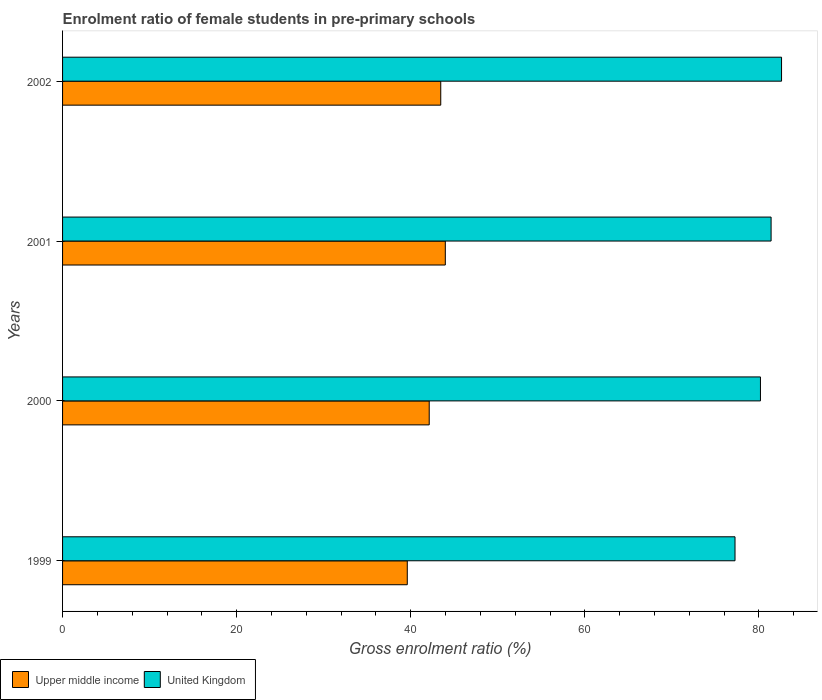How many different coloured bars are there?
Your answer should be compact. 2. Are the number of bars per tick equal to the number of legend labels?
Offer a terse response. Yes. Are the number of bars on each tick of the Y-axis equal?
Ensure brevity in your answer.  Yes. How many bars are there on the 2nd tick from the bottom?
Make the answer very short. 2. What is the label of the 2nd group of bars from the top?
Your response must be concise. 2001. What is the enrolment ratio of female students in pre-primary schools in United Kingdom in 2000?
Give a very brief answer. 80.17. Across all years, what is the maximum enrolment ratio of female students in pre-primary schools in United Kingdom?
Offer a very short reply. 82.6. Across all years, what is the minimum enrolment ratio of female students in pre-primary schools in Upper middle income?
Provide a short and direct response. 39.6. In which year was the enrolment ratio of female students in pre-primary schools in Upper middle income maximum?
Your answer should be very brief. 2001. In which year was the enrolment ratio of female students in pre-primary schools in Upper middle income minimum?
Keep it short and to the point. 1999. What is the total enrolment ratio of female students in pre-primary schools in United Kingdom in the graph?
Provide a succinct answer. 321.42. What is the difference between the enrolment ratio of female students in pre-primary schools in United Kingdom in 1999 and that in 2000?
Keep it short and to the point. -2.92. What is the difference between the enrolment ratio of female students in pre-primary schools in Upper middle income in 1999 and the enrolment ratio of female students in pre-primary schools in United Kingdom in 2002?
Offer a terse response. -43. What is the average enrolment ratio of female students in pre-primary schools in Upper middle income per year?
Keep it short and to the point. 42.29. In the year 2001, what is the difference between the enrolment ratio of female students in pre-primary schools in United Kingdom and enrolment ratio of female students in pre-primary schools in Upper middle income?
Offer a terse response. 37.43. What is the ratio of the enrolment ratio of female students in pre-primary schools in United Kingdom in 2000 to that in 2001?
Keep it short and to the point. 0.98. Is the enrolment ratio of female students in pre-primary schools in Upper middle income in 2000 less than that in 2001?
Give a very brief answer. Yes. Is the difference between the enrolment ratio of female students in pre-primary schools in United Kingdom in 2000 and 2002 greater than the difference between the enrolment ratio of female students in pre-primary schools in Upper middle income in 2000 and 2002?
Provide a succinct answer. No. What is the difference between the highest and the second highest enrolment ratio of female students in pre-primary schools in United Kingdom?
Provide a short and direct response. 1.2. What is the difference between the highest and the lowest enrolment ratio of female students in pre-primary schools in Upper middle income?
Your answer should be very brief. 4.37. What does the 1st bar from the bottom in 2000 represents?
Provide a succinct answer. Upper middle income. Are all the bars in the graph horizontal?
Ensure brevity in your answer.  Yes. What is the difference between two consecutive major ticks on the X-axis?
Offer a terse response. 20. Are the values on the major ticks of X-axis written in scientific E-notation?
Your answer should be compact. No. Where does the legend appear in the graph?
Your answer should be very brief. Bottom left. How are the legend labels stacked?
Offer a terse response. Horizontal. What is the title of the graph?
Give a very brief answer. Enrolment ratio of female students in pre-primary schools. Does "United States" appear as one of the legend labels in the graph?
Your answer should be very brief. No. What is the label or title of the X-axis?
Keep it short and to the point. Gross enrolment ratio (%). What is the label or title of the Y-axis?
Make the answer very short. Years. What is the Gross enrolment ratio (%) of Upper middle income in 1999?
Offer a terse response. 39.6. What is the Gross enrolment ratio (%) of United Kingdom in 1999?
Offer a very short reply. 77.25. What is the Gross enrolment ratio (%) in Upper middle income in 2000?
Your response must be concise. 42.12. What is the Gross enrolment ratio (%) of United Kingdom in 2000?
Offer a very short reply. 80.17. What is the Gross enrolment ratio (%) in Upper middle income in 2001?
Give a very brief answer. 43.97. What is the Gross enrolment ratio (%) of United Kingdom in 2001?
Offer a terse response. 81.4. What is the Gross enrolment ratio (%) in Upper middle income in 2002?
Provide a short and direct response. 43.45. What is the Gross enrolment ratio (%) in United Kingdom in 2002?
Provide a succinct answer. 82.6. Across all years, what is the maximum Gross enrolment ratio (%) of Upper middle income?
Ensure brevity in your answer.  43.97. Across all years, what is the maximum Gross enrolment ratio (%) of United Kingdom?
Keep it short and to the point. 82.6. Across all years, what is the minimum Gross enrolment ratio (%) of Upper middle income?
Provide a short and direct response. 39.6. Across all years, what is the minimum Gross enrolment ratio (%) in United Kingdom?
Keep it short and to the point. 77.25. What is the total Gross enrolment ratio (%) in Upper middle income in the graph?
Provide a short and direct response. 169.14. What is the total Gross enrolment ratio (%) in United Kingdom in the graph?
Ensure brevity in your answer.  321.42. What is the difference between the Gross enrolment ratio (%) in Upper middle income in 1999 and that in 2000?
Keep it short and to the point. -2.52. What is the difference between the Gross enrolment ratio (%) in United Kingdom in 1999 and that in 2000?
Your answer should be very brief. -2.92. What is the difference between the Gross enrolment ratio (%) in Upper middle income in 1999 and that in 2001?
Give a very brief answer. -4.37. What is the difference between the Gross enrolment ratio (%) in United Kingdom in 1999 and that in 2001?
Offer a terse response. -4.14. What is the difference between the Gross enrolment ratio (%) of Upper middle income in 1999 and that in 2002?
Offer a terse response. -3.84. What is the difference between the Gross enrolment ratio (%) of United Kingdom in 1999 and that in 2002?
Provide a short and direct response. -5.34. What is the difference between the Gross enrolment ratio (%) of Upper middle income in 2000 and that in 2001?
Provide a short and direct response. -1.85. What is the difference between the Gross enrolment ratio (%) of United Kingdom in 2000 and that in 2001?
Your answer should be compact. -1.22. What is the difference between the Gross enrolment ratio (%) in Upper middle income in 2000 and that in 2002?
Offer a terse response. -1.33. What is the difference between the Gross enrolment ratio (%) of United Kingdom in 2000 and that in 2002?
Ensure brevity in your answer.  -2.42. What is the difference between the Gross enrolment ratio (%) in Upper middle income in 2001 and that in 2002?
Offer a very short reply. 0.52. What is the difference between the Gross enrolment ratio (%) in United Kingdom in 2001 and that in 2002?
Ensure brevity in your answer.  -1.2. What is the difference between the Gross enrolment ratio (%) of Upper middle income in 1999 and the Gross enrolment ratio (%) of United Kingdom in 2000?
Provide a short and direct response. -40.57. What is the difference between the Gross enrolment ratio (%) in Upper middle income in 1999 and the Gross enrolment ratio (%) in United Kingdom in 2001?
Keep it short and to the point. -41.79. What is the difference between the Gross enrolment ratio (%) in Upper middle income in 1999 and the Gross enrolment ratio (%) in United Kingdom in 2002?
Give a very brief answer. -43. What is the difference between the Gross enrolment ratio (%) in Upper middle income in 2000 and the Gross enrolment ratio (%) in United Kingdom in 2001?
Your response must be concise. -39.27. What is the difference between the Gross enrolment ratio (%) in Upper middle income in 2000 and the Gross enrolment ratio (%) in United Kingdom in 2002?
Your answer should be very brief. -40.48. What is the difference between the Gross enrolment ratio (%) of Upper middle income in 2001 and the Gross enrolment ratio (%) of United Kingdom in 2002?
Your answer should be compact. -38.63. What is the average Gross enrolment ratio (%) in Upper middle income per year?
Ensure brevity in your answer.  42.29. What is the average Gross enrolment ratio (%) in United Kingdom per year?
Give a very brief answer. 80.36. In the year 1999, what is the difference between the Gross enrolment ratio (%) of Upper middle income and Gross enrolment ratio (%) of United Kingdom?
Offer a terse response. -37.65. In the year 2000, what is the difference between the Gross enrolment ratio (%) in Upper middle income and Gross enrolment ratio (%) in United Kingdom?
Offer a very short reply. -38.05. In the year 2001, what is the difference between the Gross enrolment ratio (%) of Upper middle income and Gross enrolment ratio (%) of United Kingdom?
Provide a succinct answer. -37.43. In the year 2002, what is the difference between the Gross enrolment ratio (%) of Upper middle income and Gross enrolment ratio (%) of United Kingdom?
Offer a very short reply. -39.15. What is the ratio of the Gross enrolment ratio (%) of Upper middle income in 1999 to that in 2000?
Provide a short and direct response. 0.94. What is the ratio of the Gross enrolment ratio (%) of United Kingdom in 1999 to that in 2000?
Offer a terse response. 0.96. What is the ratio of the Gross enrolment ratio (%) of Upper middle income in 1999 to that in 2001?
Offer a very short reply. 0.9. What is the ratio of the Gross enrolment ratio (%) in United Kingdom in 1999 to that in 2001?
Your response must be concise. 0.95. What is the ratio of the Gross enrolment ratio (%) in Upper middle income in 1999 to that in 2002?
Provide a short and direct response. 0.91. What is the ratio of the Gross enrolment ratio (%) of United Kingdom in 1999 to that in 2002?
Give a very brief answer. 0.94. What is the ratio of the Gross enrolment ratio (%) in Upper middle income in 2000 to that in 2001?
Provide a succinct answer. 0.96. What is the ratio of the Gross enrolment ratio (%) in United Kingdom in 2000 to that in 2001?
Keep it short and to the point. 0.98. What is the ratio of the Gross enrolment ratio (%) in Upper middle income in 2000 to that in 2002?
Give a very brief answer. 0.97. What is the ratio of the Gross enrolment ratio (%) of United Kingdom in 2000 to that in 2002?
Make the answer very short. 0.97. What is the ratio of the Gross enrolment ratio (%) of United Kingdom in 2001 to that in 2002?
Ensure brevity in your answer.  0.99. What is the difference between the highest and the second highest Gross enrolment ratio (%) of Upper middle income?
Give a very brief answer. 0.52. What is the difference between the highest and the second highest Gross enrolment ratio (%) in United Kingdom?
Your answer should be very brief. 1.2. What is the difference between the highest and the lowest Gross enrolment ratio (%) in Upper middle income?
Your response must be concise. 4.37. What is the difference between the highest and the lowest Gross enrolment ratio (%) in United Kingdom?
Ensure brevity in your answer.  5.34. 